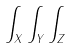<formula> <loc_0><loc_0><loc_500><loc_500>\int _ { X } \int _ { Y } \int _ { Z }</formula> 